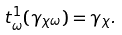<formula> <loc_0><loc_0><loc_500><loc_500>t _ { \omega } ^ { 1 } ( \gamma _ { \chi \omega } ) = \gamma _ { \chi } .</formula> 